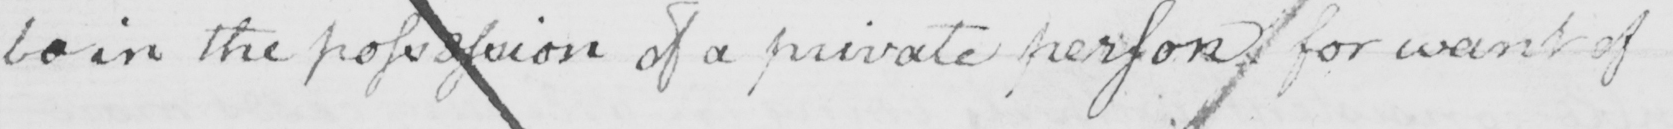Please provide the text content of this handwritten line. be in the possession of a private person for want of 